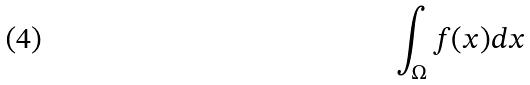Convert formula to latex. <formula><loc_0><loc_0><loc_500><loc_500>\int _ { \Omega } f ( x ) d x</formula> 